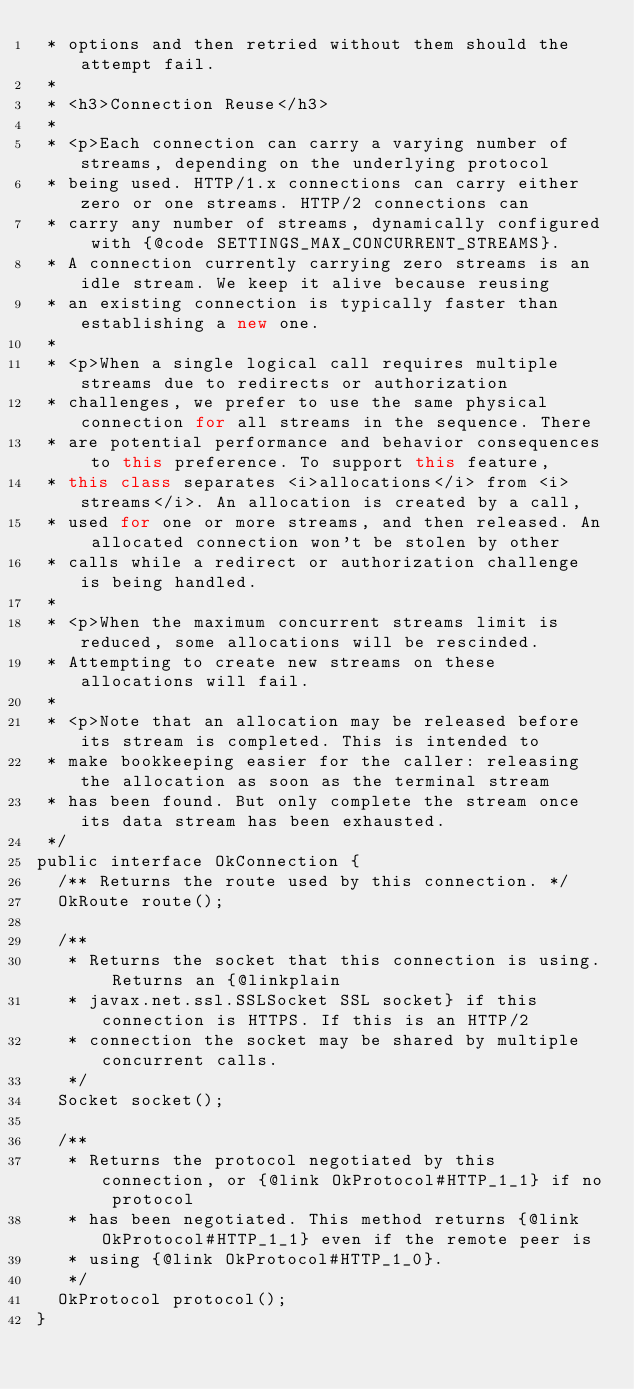Convert code to text. <code><loc_0><loc_0><loc_500><loc_500><_Java_> * options and then retried without them should the attempt fail.
 *
 * <h3>Connection Reuse</h3>
 *
 * <p>Each connection can carry a varying number of streams, depending on the underlying protocol
 * being used. HTTP/1.x connections can carry either zero or one streams. HTTP/2 connections can
 * carry any number of streams, dynamically configured with {@code SETTINGS_MAX_CONCURRENT_STREAMS}.
 * A connection currently carrying zero streams is an idle stream. We keep it alive because reusing
 * an existing connection is typically faster than establishing a new one.
 *
 * <p>When a single logical call requires multiple streams due to redirects or authorization
 * challenges, we prefer to use the same physical connection for all streams in the sequence. There
 * are potential performance and behavior consequences to this preference. To support this feature,
 * this class separates <i>allocations</i> from <i>streams</i>. An allocation is created by a call,
 * used for one or more streams, and then released. An allocated connection won't be stolen by other
 * calls while a redirect or authorization challenge is being handled.
 *
 * <p>When the maximum concurrent streams limit is reduced, some allocations will be rescinded.
 * Attempting to create new streams on these allocations will fail.
 *
 * <p>Note that an allocation may be released before its stream is completed. This is intended to
 * make bookkeeping easier for the caller: releasing the allocation as soon as the terminal stream
 * has been found. But only complete the stream once its data stream has been exhausted.
 */
public interface OkConnection {
  /** Returns the route used by this connection. */
  OkRoute route();

  /**
   * Returns the socket that this connection is using. Returns an {@linkplain
   * javax.net.ssl.SSLSocket SSL socket} if this connection is HTTPS. If this is an HTTP/2
   * connection the socket may be shared by multiple concurrent calls.
   */
  Socket socket();

  /**
   * Returns the protocol negotiated by this connection, or {@link OkProtocol#HTTP_1_1} if no protocol
   * has been negotiated. This method returns {@link OkProtocol#HTTP_1_1} even if the remote peer is
   * using {@link OkProtocol#HTTP_1_0}.
   */
  OkProtocol protocol();
}
</code> 